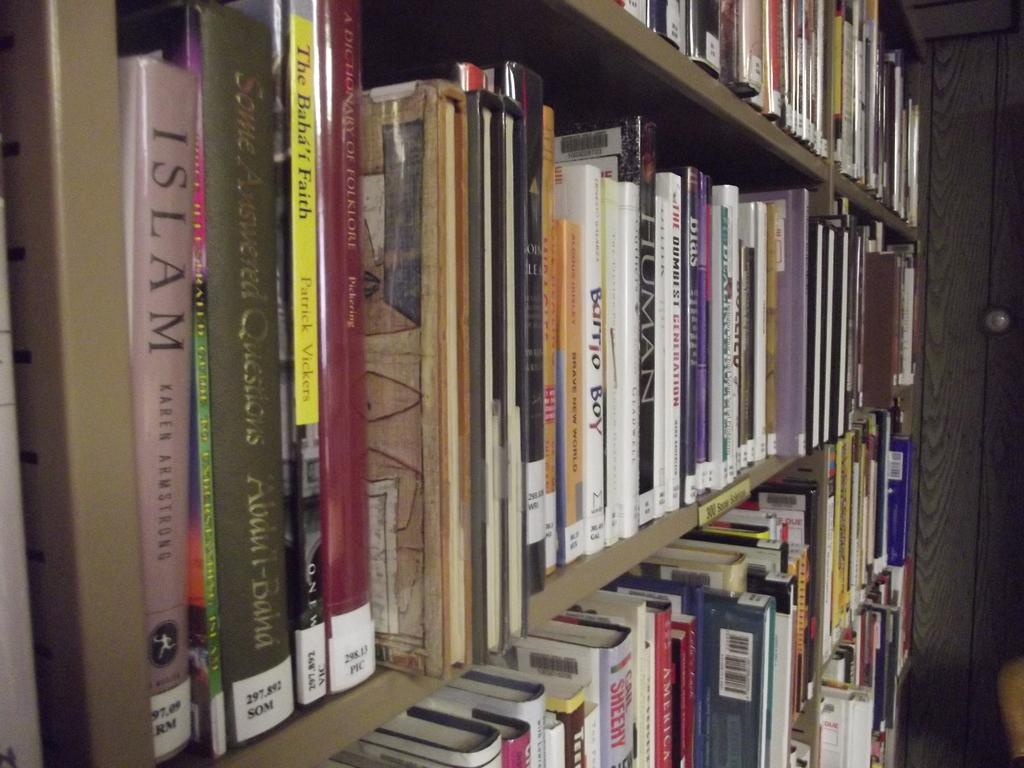<image>
Present a compact description of the photo's key features. A large book shelf filled with many books starting with the book, Islam by Karen Armstrong on the middle shelf. 